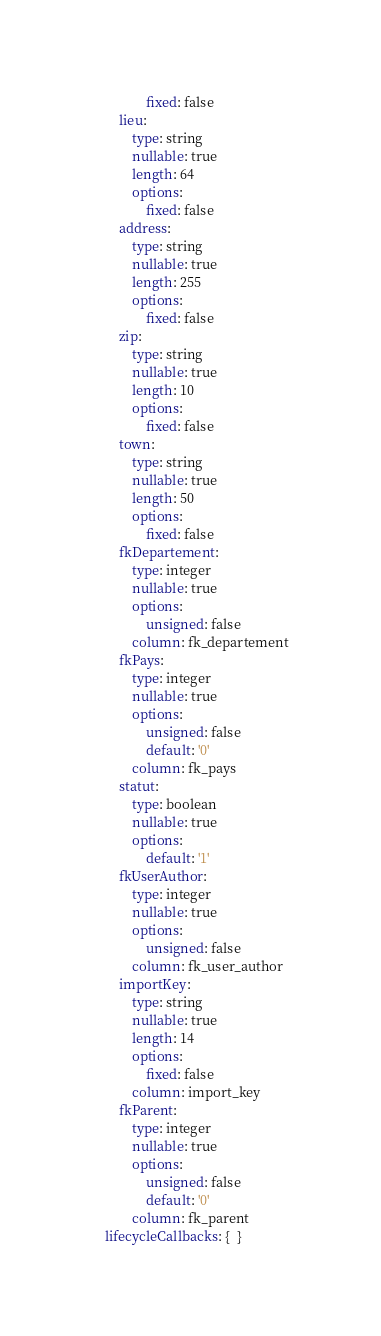<code> <loc_0><loc_0><loc_500><loc_500><_YAML_>                fixed: false
        lieu:
            type: string
            nullable: true
            length: 64
            options:
                fixed: false
        address:
            type: string
            nullable: true
            length: 255
            options:
                fixed: false
        zip:
            type: string
            nullable: true
            length: 10
            options:
                fixed: false
        town:
            type: string
            nullable: true
            length: 50
            options:
                fixed: false
        fkDepartement:
            type: integer
            nullable: true
            options:
                unsigned: false
            column: fk_departement
        fkPays:
            type: integer
            nullable: true
            options:
                unsigned: false
                default: '0'
            column: fk_pays
        statut:
            type: boolean
            nullable: true
            options:
                default: '1'
        fkUserAuthor:
            type: integer
            nullable: true
            options:
                unsigned: false
            column: fk_user_author
        importKey:
            type: string
            nullable: true
            length: 14
            options:
                fixed: false
            column: import_key
        fkParent:
            type: integer
            nullable: true
            options:
                unsigned: false
                default: '0'
            column: fk_parent
    lifecycleCallbacks: {  }
</code> 